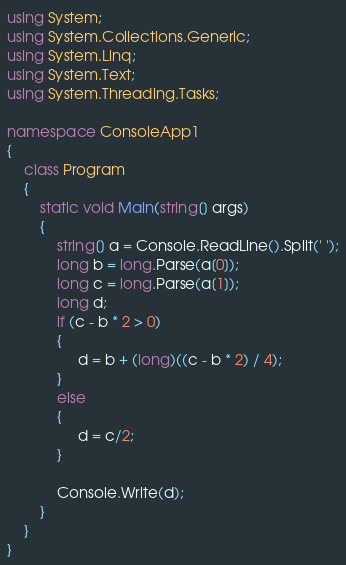Convert code to text. <code><loc_0><loc_0><loc_500><loc_500><_C#_>using System;
using System.Collections.Generic;
using System.Linq;
using System.Text;
using System.Threading.Tasks;

namespace ConsoleApp1
{
    class Program
    {
        static void Main(string[] args)
        {
            string[] a = Console.ReadLine().Split(' ');
            long b = long.Parse(a[0]);
            long c = long.Parse(a[1]);
            long d;
            if (c - b * 2 > 0)
            {
                 d = b + (long)((c - b * 2) / 4);
            }
            else
            {
                 d = c/2;
            }

            Console.Write(d);
        }
    }
}
</code> 